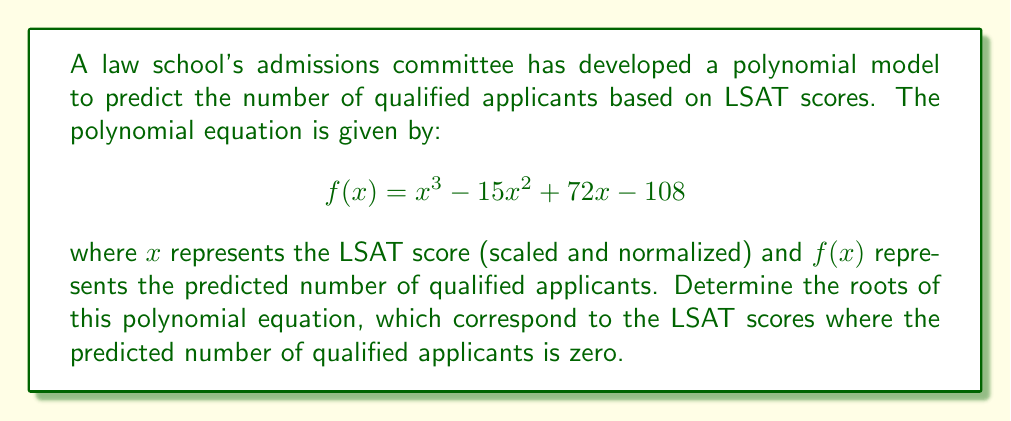Can you solve this math problem? To find the roots of the polynomial equation, we need to factor the polynomial $f(x) = x^3 - 15x^2 + 72x - 108$. Let's approach this step-by-step:

1) First, let's check if there's a common factor:
   There is no common factor for all terms.

2) Next, let's try to guess one root. Given the constant term is -108, possible factors are ±1, ±2, ±3, ±4, ±6, ±9, ±12, ±18, ±27, ±36, ±54, ±108.
   By trial and error or using the rational root theorem, we can find that 3 is a root.

3) Divide the polynomial by $(x - 3)$:
   $$\frac{x^3 - 15x^2 + 72x - 108}{x - 3} = x^2 - 12x + 36$$

4) The quadratic factor $x^2 - 12x + 36$ can be factored further:
   $$x^2 - 12x + 36 = (x - 6)(x - 6)$$

5) Therefore, the complete factorization is:
   $$f(x) = (x - 3)(x - 6)^2$$

6) The roots of the polynomial are the values of x that make each factor equal to zero:
   $x - 3 = 0$ gives $x = 3$
   $(x - 6)^2 = 0$ gives $x = 6$ (with multiplicity 2)

Thus, the roots of the polynomial are 3 and 6 (repeated).
Answer: $x = 3$ and $x = 6$ (double root) 